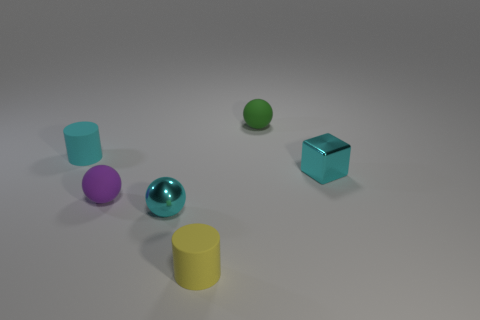Subtract all tiny rubber balls. How many balls are left? 1 Add 2 tiny purple matte balls. How many objects exist? 8 Subtract all cyan cylinders. How many cylinders are left? 1 Subtract all green balls. How many cyan cylinders are left? 1 Add 4 big green matte blocks. How many big green matte blocks exist? 4 Subtract 0 purple cylinders. How many objects are left? 6 Subtract all cylinders. How many objects are left? 4 Subtract 1 blocks. How many blocks are left? 0 Subtract all blue cylinders. Subtract all red spheres. How many cylinders are left? 2 Subtract all purple shiny cylinders. Subtract all green spheres. How many objects are left? 5 